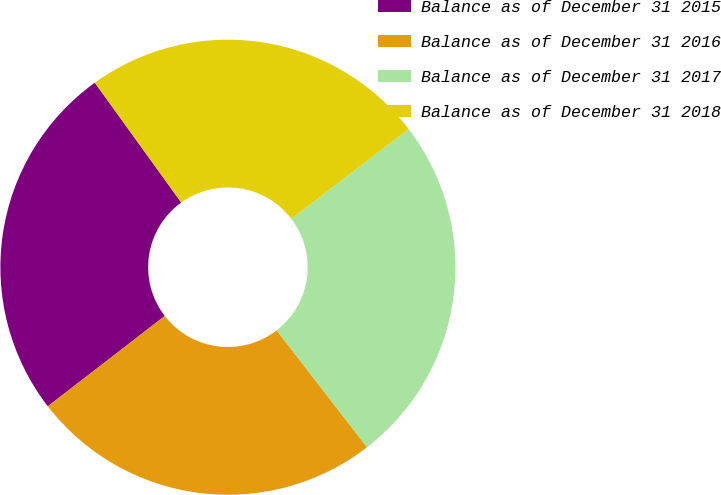<chart> <loc_0><loc_0><loc_500><loc_500><pie_chart><fcel>Balance as of December 31 2015<fcel>Balance as of December 31 2016<fcel>Balance as of December 31 2017<fcel>Balance as of December 31 2018<nl><fcel>25.52%<fcel>25.0%<fcel>24.91%<fcel>24.56%<nl></chart> 